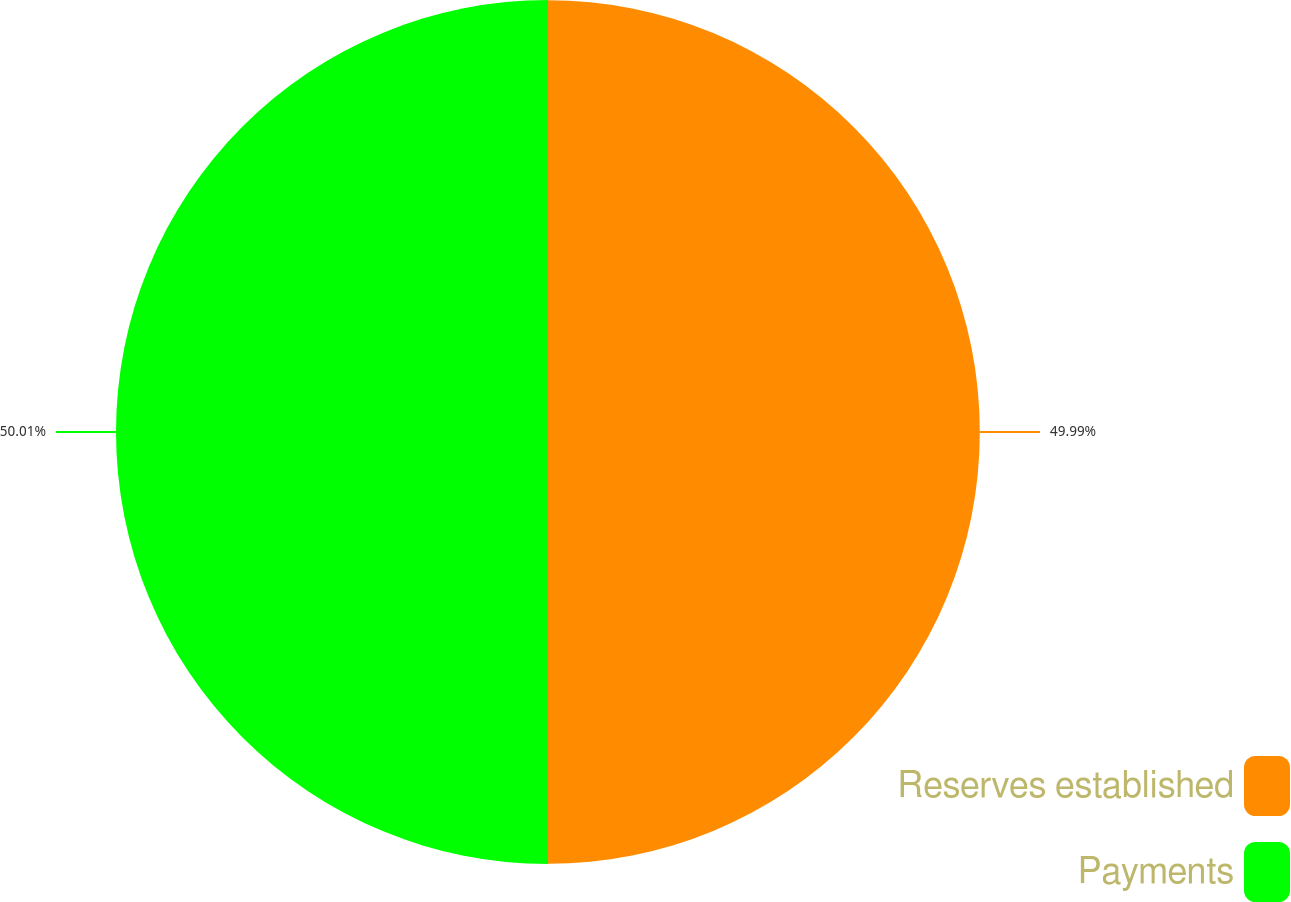<chart> <loc_0><loc_0><loc_500><loc_500><pie_chart><fcel>Reserves established<fcel>Payments<nl><fcel>49.99%<fcel>50.01%<nl></chart> 